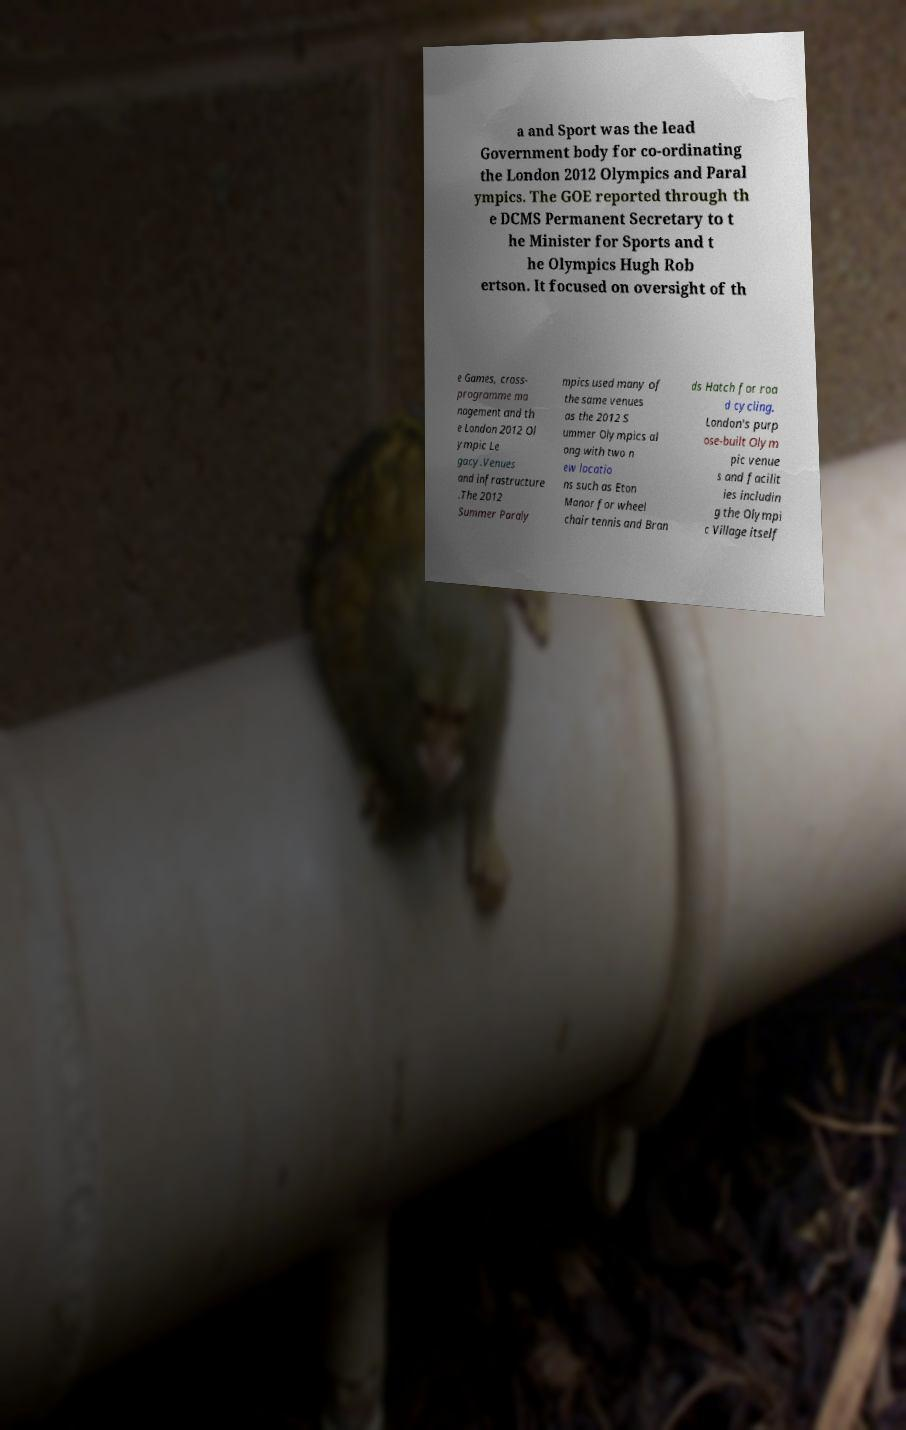I need the written content from this picture converted into text. Can you do that? a and Sport was the lead Government body for co-ordinating the London 2012 Olympics and Paral ympics. The GOE reported through th e DCMS Permanent Secretary to t he Minister for Sports and t he Olympics Hugh Rob ertson. It focused on oversight of th e Games, cross- programme ma nagement and th e London 2012 Ol ympic Le gacy.Venues and infrastructure .The 2012 Summer Paraly mpics used many of the same venues as the 2012 S ummer Olympics al ong with two n ew locatio ns such as Eton Manor for wheel chair tennis and Bran ds Hatch for roa d cycling. London's purp ose-built Olym pic venue s and facilit ies includin g the Olympi c Village itself 